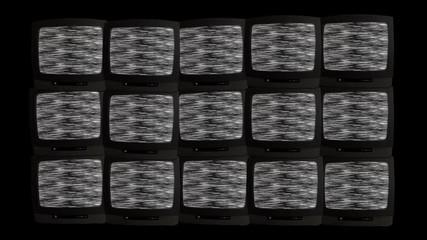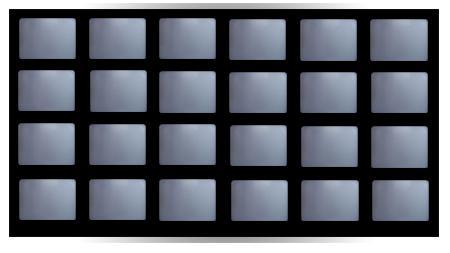The first image is the image on the left, the second image is the image on the right. Examine the images to the left and right. Is the description "There are multiple screens in the right image." accurate? Answer yes or no. Yes. 